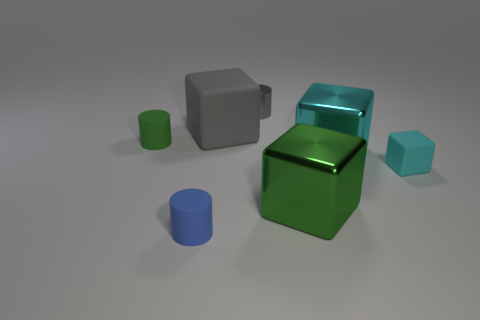Subtract all green blocks. How many blocks are left? 3 Subtract all yellow blocks. Subtract all blue cylinders. How many blocks are left? 4 Add 1 cyan metal blocks. How many objects exist? 8 Subtract all cylinders. How many objects are left? 4 Add 6 blue cylinders. How many blue cylinders exist? 7 Subtract 0 yellow cylinders. How many objects are left? 7 Subtract all green metal cubes. Subtract all big gray matte blocks. How many objects are left? 5 Add 7 metal blocks. How many metal blocks are left? 9 